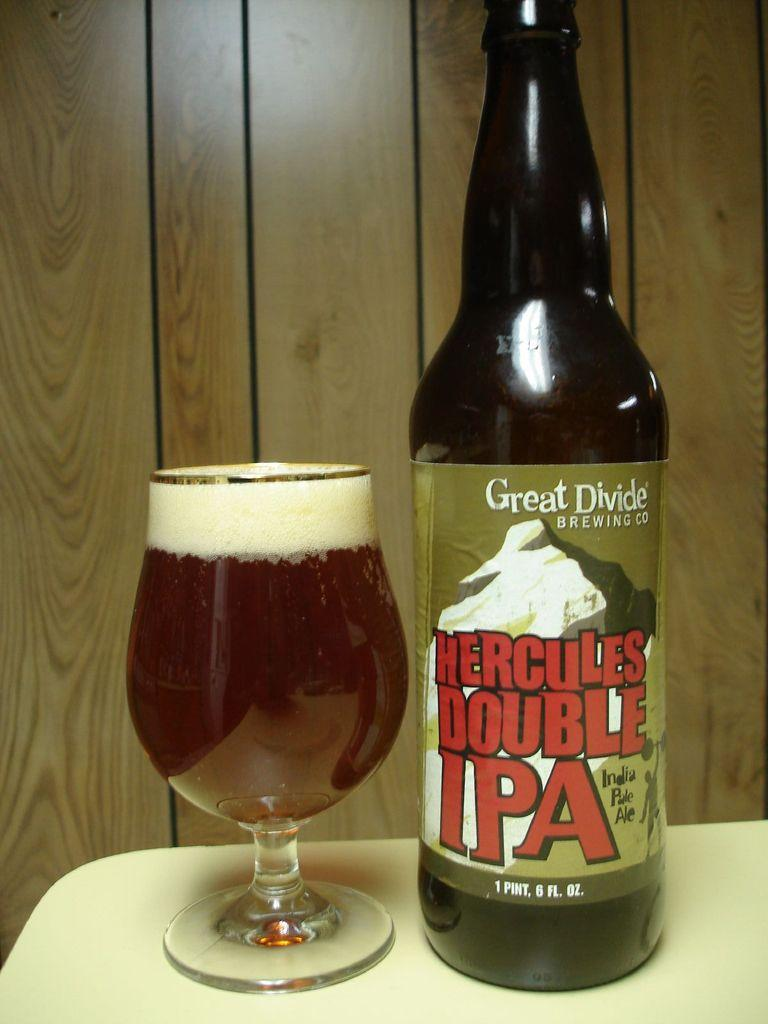<image>
Create a compact narrative representing the image presented. A bottle of Hercules Double IPA has been poured into a glass 